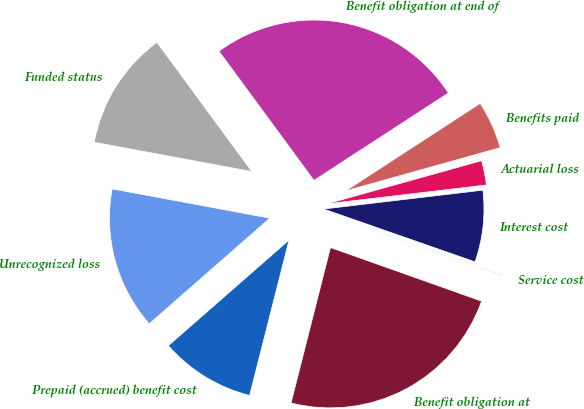Convert chart to OTSL. <chart><loc_0><loc_0><loc_500><loc_500><pie_chart><fcel>Benefit obligation at<fcel>Service cost<fcel>Interest cost<fcel>Actuarial loss<fcel>Benefits paid<fcel>Benefit obligation at end of<fcel>Funded status<fcel>Unrecognized loss<fcel>Prepaid (accrued) benefit cost<nl><fcel>23.53%<fcel>0.08%<fcel>7.22%<fcel>2.46%<fcel>4.84%<fcel>25.91%<fcel>11.99%<fcel>14.37%<fcel>9.6%<nl></chart> 